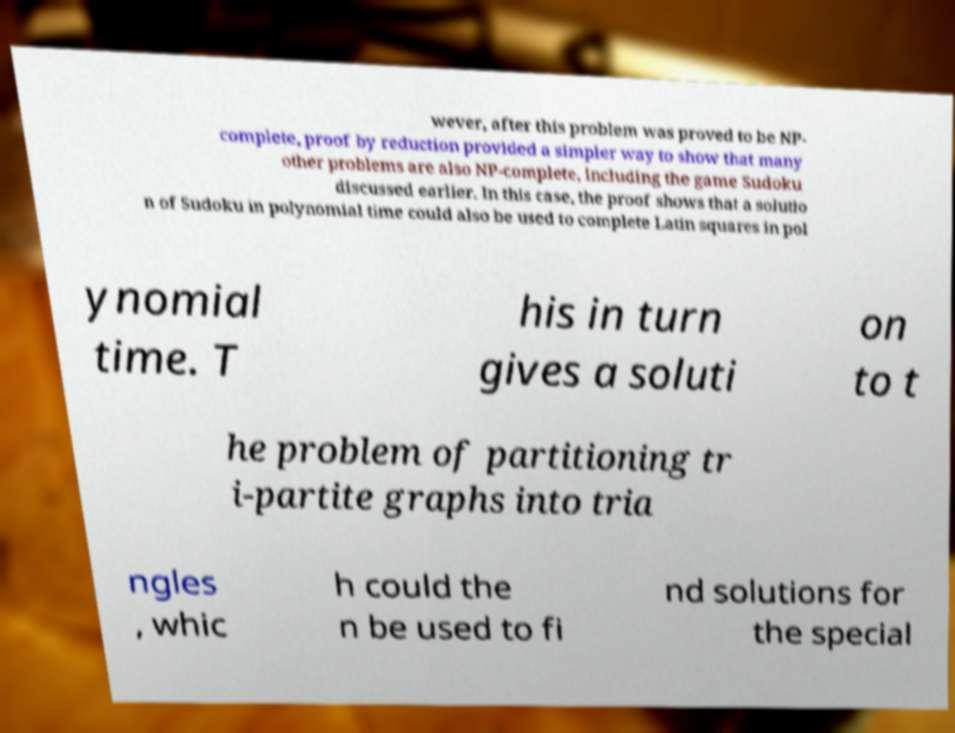Can you read and provide the text displayed in the image?This photo seems to have some interesting text. Can you extract and type it out for me? wever, after this problem was proved to be NP- complete, proof by reduction provided a simpler way to show that many other problems are also NP-complete, including the game Sudoku discussed earlier. In this case, the proof shows that a solutio n of Sudoku in polynomial time could also be used to complete Latin squares in pol ynomial time. T his in turn gives a soluti on to t he problem of partitioning tr i-partite graphs into tria ngles , whic h could the n be used to fi nd solutions for the special 